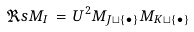<formula> <loc_0><loc_0><loc_500><loc_500>\Re s M _ { I } \, = \, U ^ { 2 } M _ { J \sqcup \{ \bullet \} } M _ { K \sqcup \{ \bullet \} }</formula> 